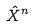Convert formula to latex. <formula><loc_0><loc_0><loc_500><loc_500>\hat { X } ^ { n }</formula> 